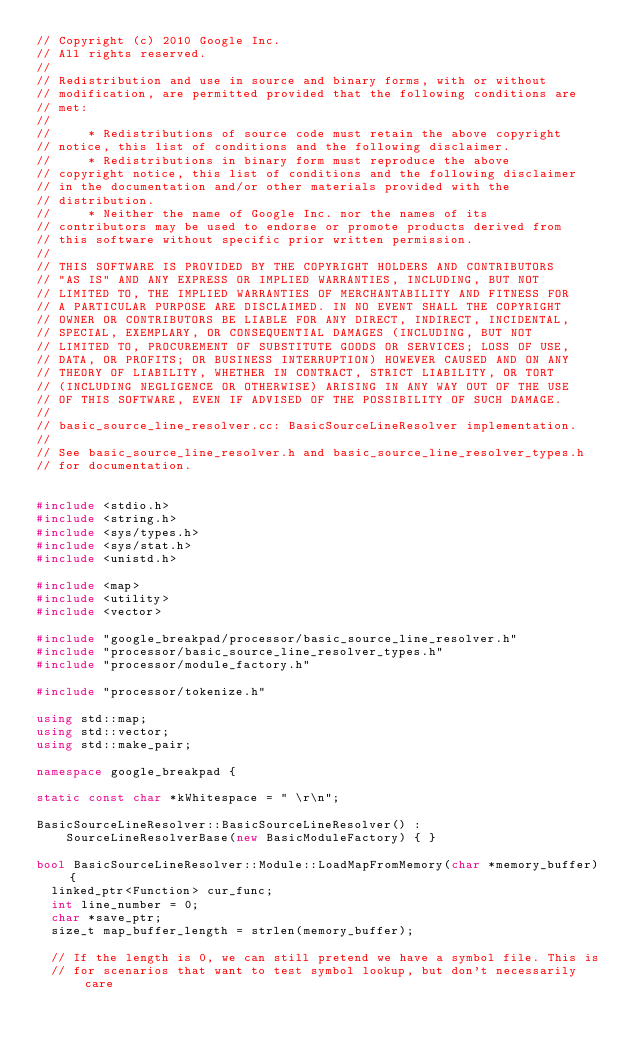Convert code to text. <code><loc_0><loc_0><loc_500><loc_500><_C++_>// Copyright (c) 2010 Google Inc.
// All rights reserved.
//
// Redistribution and use in source and binary forms, with or without
// modification, are permitted provided that the following conditions are
// met:
//
//     * Redistributions of source code must retain the above copyright
// notice, this list of conditions and the following disclaimer.
//     * Redistributions in binary form must reproduce the above
// copyright notice, this list of conditions and the following disclaimer
// in the documentation and/or other materials provided with the
// distribution.
//     * Neither the name of Google Inc. nor the names of its
// contributors may be used to endorse or promote products derived from
// this software without specific prior written permission.
//
// THIS SOFTWARE IS PROVIDED BY THE COPYRIGHT HOLDERS AND CONTRIBUTORS
// "AS IS" AND ANY EXPRESS OR IMPLIED WARRANTIES, INCLUDING, BUT NOT
// LIMITED TO, THE IMPLIED WARRANTIES OF MERCHANTABILITY AND FITNESS FOR
// A PARTICULAR PURPOSE ARE DISCLAIMED. IN NO EVENT SHALL THE COPYRIGHT
// OWNER OR CONTRIBUTORS BE LIABLE FOR ANY DIRECT, INDIRECT, INCIDENTAL,
// SPECIAL, EXEMPLARY, OR CONSEQUENTIAL DAMAGES (INCLUDING, BUT NOT
// LIMITED TO, PROCUREMENT OF SUBSTITUTE GOODS OR SERVICES; LOSS OF USE,
// DATA, OR PROFITS; OR BUSINESS INTERRUPTION) HOWEVER CAUSED AND ON ANY
// THEORY OF LIABILITY, WHETHER IN CONTRACT, STRICT LIABILITY, OR TORT
// (INCLUDING NEGLIGENCE OR OTHERWISE) ARISING IN ANY WAY OUT OF THE USE
// OF THIS SOFTWARE, EVEN IF ADVISED OF THE POSSIBILITY OF SUCH DAMAGE.
//
// basic_source_line_resolver.cc: BasicSourceLineResolver implementation.
//
// See basic_source_line_resolver.h and basic_source_line_resolver_types.h
// for documentation.


#include <stdio.h>
#include <string.h>
#include <sys/types.h>
#include <sys/stat.h>
#include <unistd.h>

#include <map>
#include <utility>
#include <vector>

#include "google_breakpad/processor/basic_source_line_resolver.h"
#include "processor/basic_source_line_resolver_types.h"
#include "processor/module_factory.h"

#include "processor/tokenize.h"

using std::map;
using std::vector;
using std::make_pair;

namespace google_breakpad {

static const char *kWhitespace = " \r\n";

BasicSourceLineResolver::BasicSourceLineResolver() :
    SourceLineResolverBase(new BasicModuleFactory) { }

bool BasicSourceLineResolver::Module::LoadMapFromMemory(char *memory_buffer) {
  linked_ptr<Function> cur_func;
  int line_number = 0;
  char *save_ptr;
  size_t map_buffer_length = strlen(memory_buffer);

  // If the length is 0, we can still pretend we have a symbol file. This is
  // for scenarios that want to test symbol lookup, but don't necessarily care</code> 